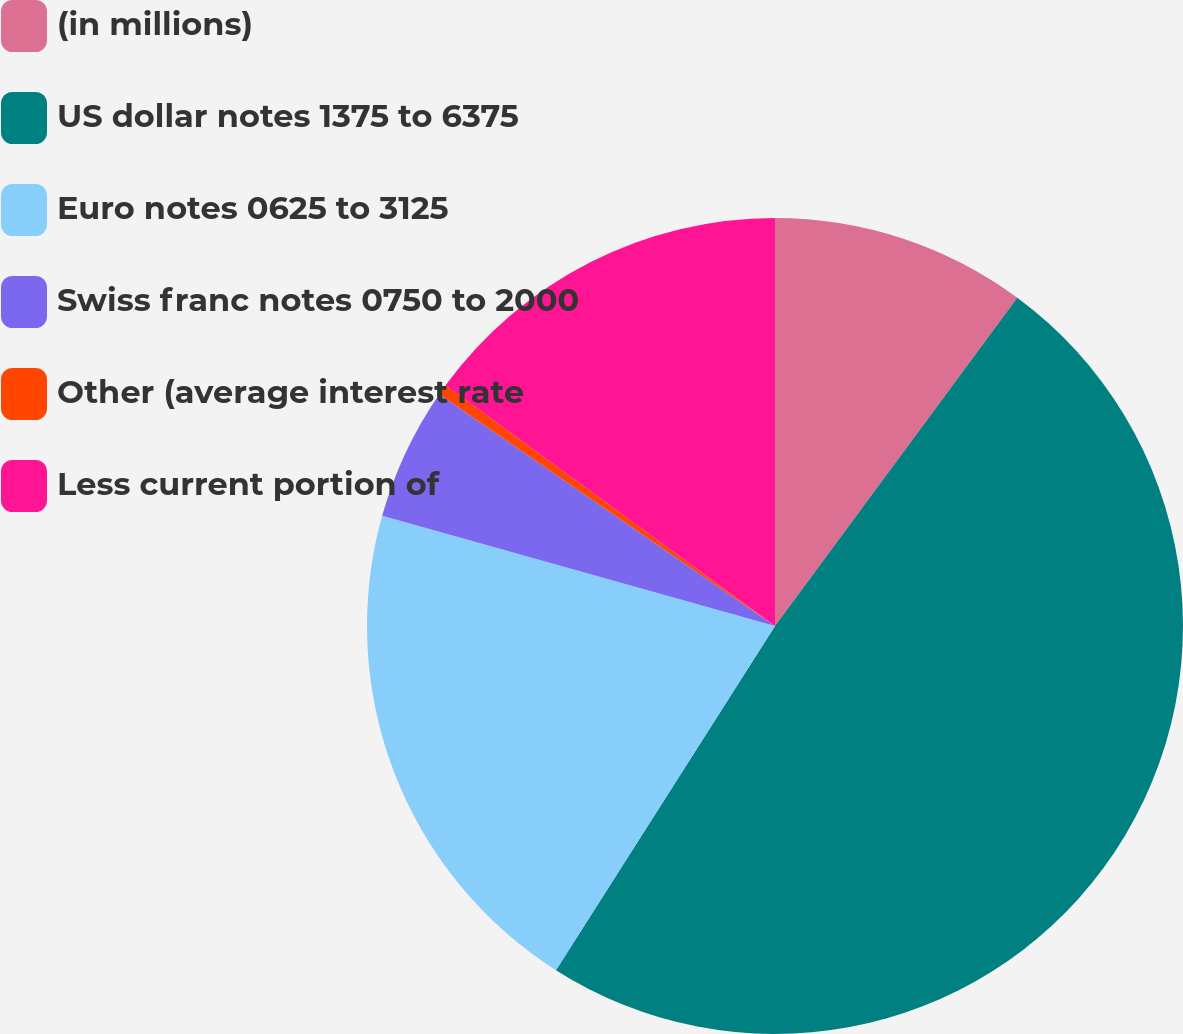Convert chart. <chart><loc_0><loc_0><loc_500><loc_500><pie_chart><fcel>(in millions)<fcel>US dollar notes 1375 to 6375<fcel>Euro notes 0625 to 3125<fcel>Swiss franc notes 0750 to 2000<fcel>Other (average interest rate<fcel>Less current portion of<nl><fcel>10.12%<fcel>48.9%<fcel>20.33%<fcel>5.27%<fcel>0.42%<fcel>14.96%<nl></chart> 